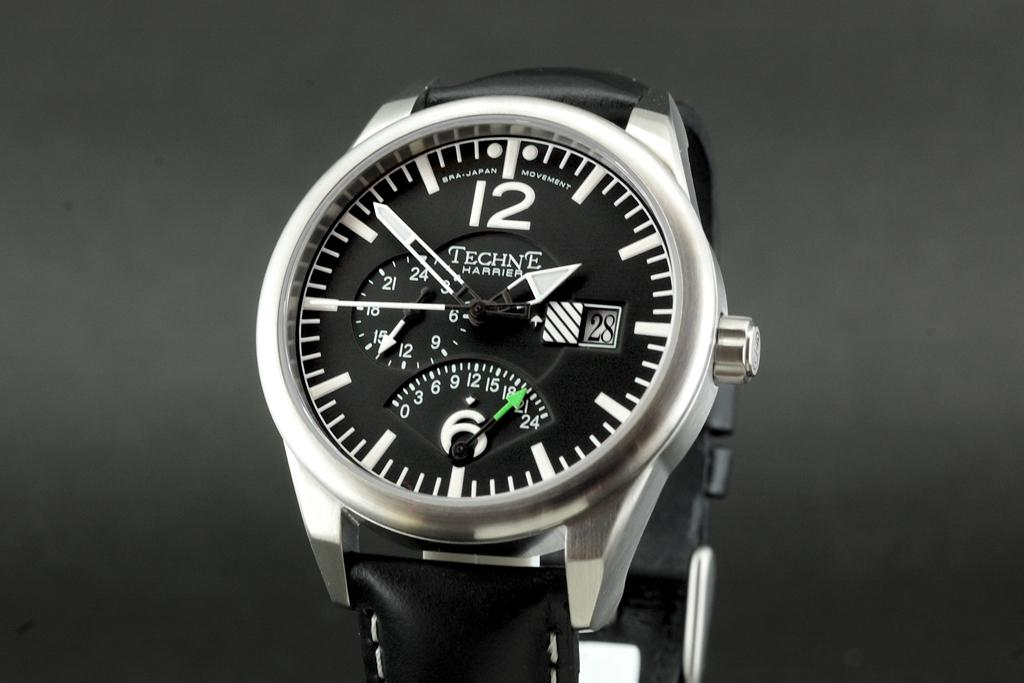<image>
Present a compact description of the photo's key features. A black and white Techne Harrier Wrist Watch. 